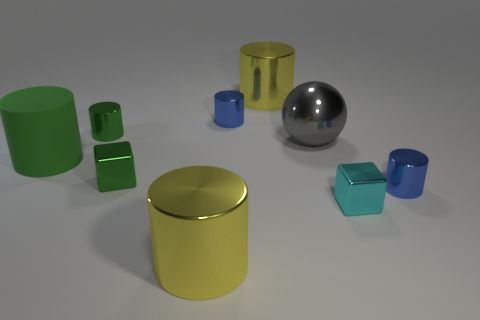What material is the cyan thing?
Provide a short and direct response. Metal. What number of purple balls have the same material as the small cyan thing?
Your answer should be compact. 0. What number of metal objects are big brown cylinders or big green cylinders?
Your answer should be compact. 0. Is the shape of the yellow metal thing behind the cyan shiny cube the same as the small blue object that is behind the green metallic cube?
Offer a terse response. Yes. The tiny thing that is on the right side of the tiny green cylinder and behind the big sphere is what color?
Your answer should be very brief. Blue. There is a shiny cube that is on the left side of the cyan thing; is it the same size as the matte cylinder on the left side of the cyan shiny cube?
Offer a terse response. No. How many small metallic cubes have the same color as the shiny sphere?
Offer a very short reply. 0. What number of tiny objects are gray shiny spheres or green matte spheres?
Provide a short and direct response. 0. Is the tiny cylinder behind the small green shiny cylinder made of the same material as the cyan object?
Your response must be concise. Yes. There is a big thing that is in front of the matte thing; what is its color?
Ensure brevity in your answer.  Yellow. 